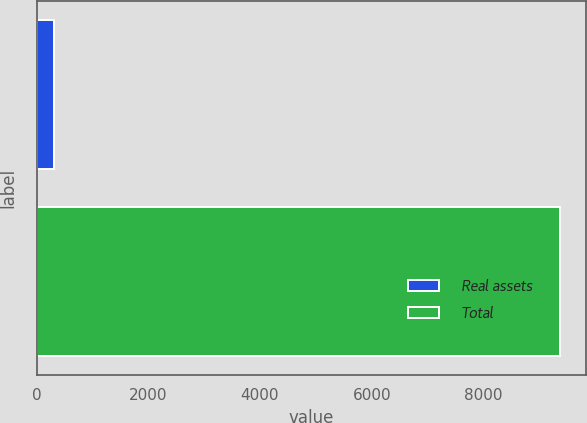Convert chart to OTSL. <chart><loc_0><loc_0><loc_500><loc_500><bar_chart><fcel>Real assets<fcel>Total<nl><fcel>311<fcel>9375<nl></chart> 